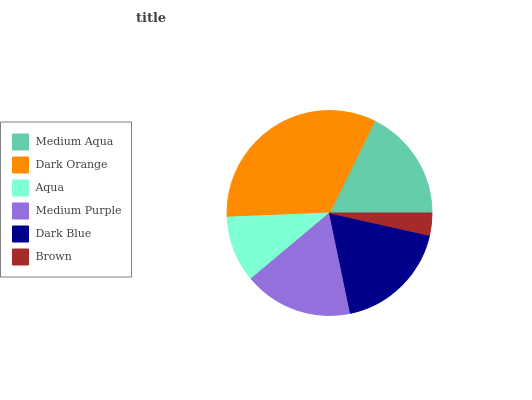Is Brown the minimum?
Answer yes or no. Yes. Is Dark Orange the maximum?
Answer yes or no. Yes. Is Aqua the minimum?
Answer yes or no. No. Is Aqua the maximum?
Answer yes or no. No. Is Dark Orange greater than Aqua?
Answer yes or no. Yes. Is Aqua less than Dark Orange?
Answer yes or no. Yes. Is Aqua greater than Dark Orange?
Answer yes or no. No. Is Dark Orange less than Aqua?
Answer yes or no. No. Is Medium Aqua the high median?
Answer yes or no. Yes. Is Medium Purple the low median?
Answer yes or no. Yes. Is Brown the high median?
Answer yes or no. No. Is Brown the low median?
Answer yes or no. No. 